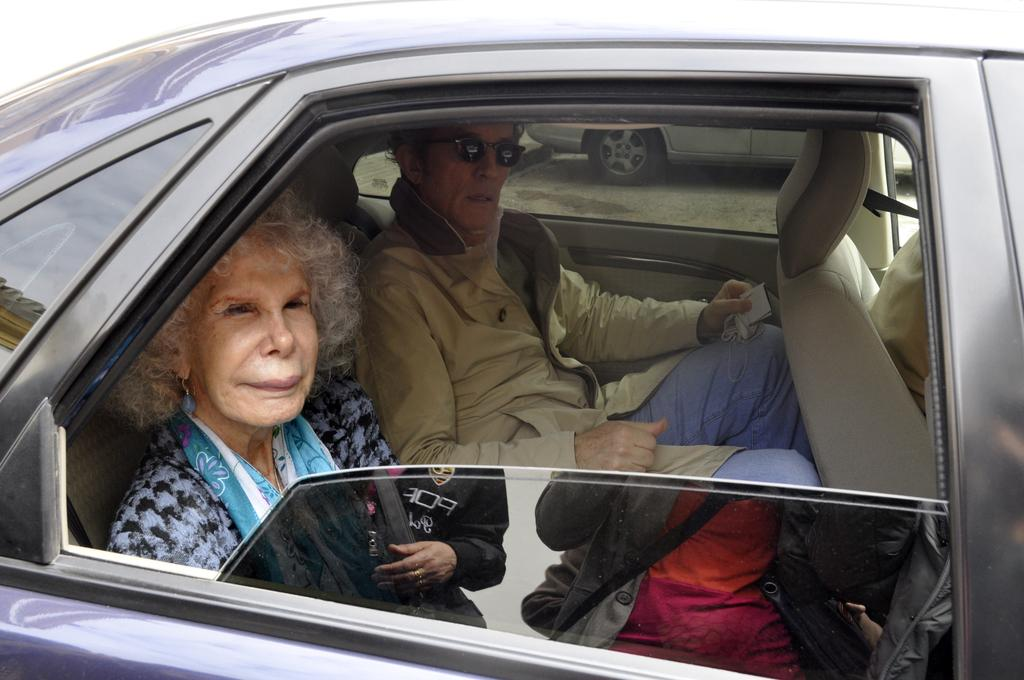What is the main subject of the image? The main subject of the image is a car. Can you describe the car in the image? The car is black. Who is inside the car? There are two people sitting in the car, a woman and a man. What type of leather is covering the knee of the woman in the image? There is no leather or mention of a knee in the image; it only shows a black car with two people inside. 